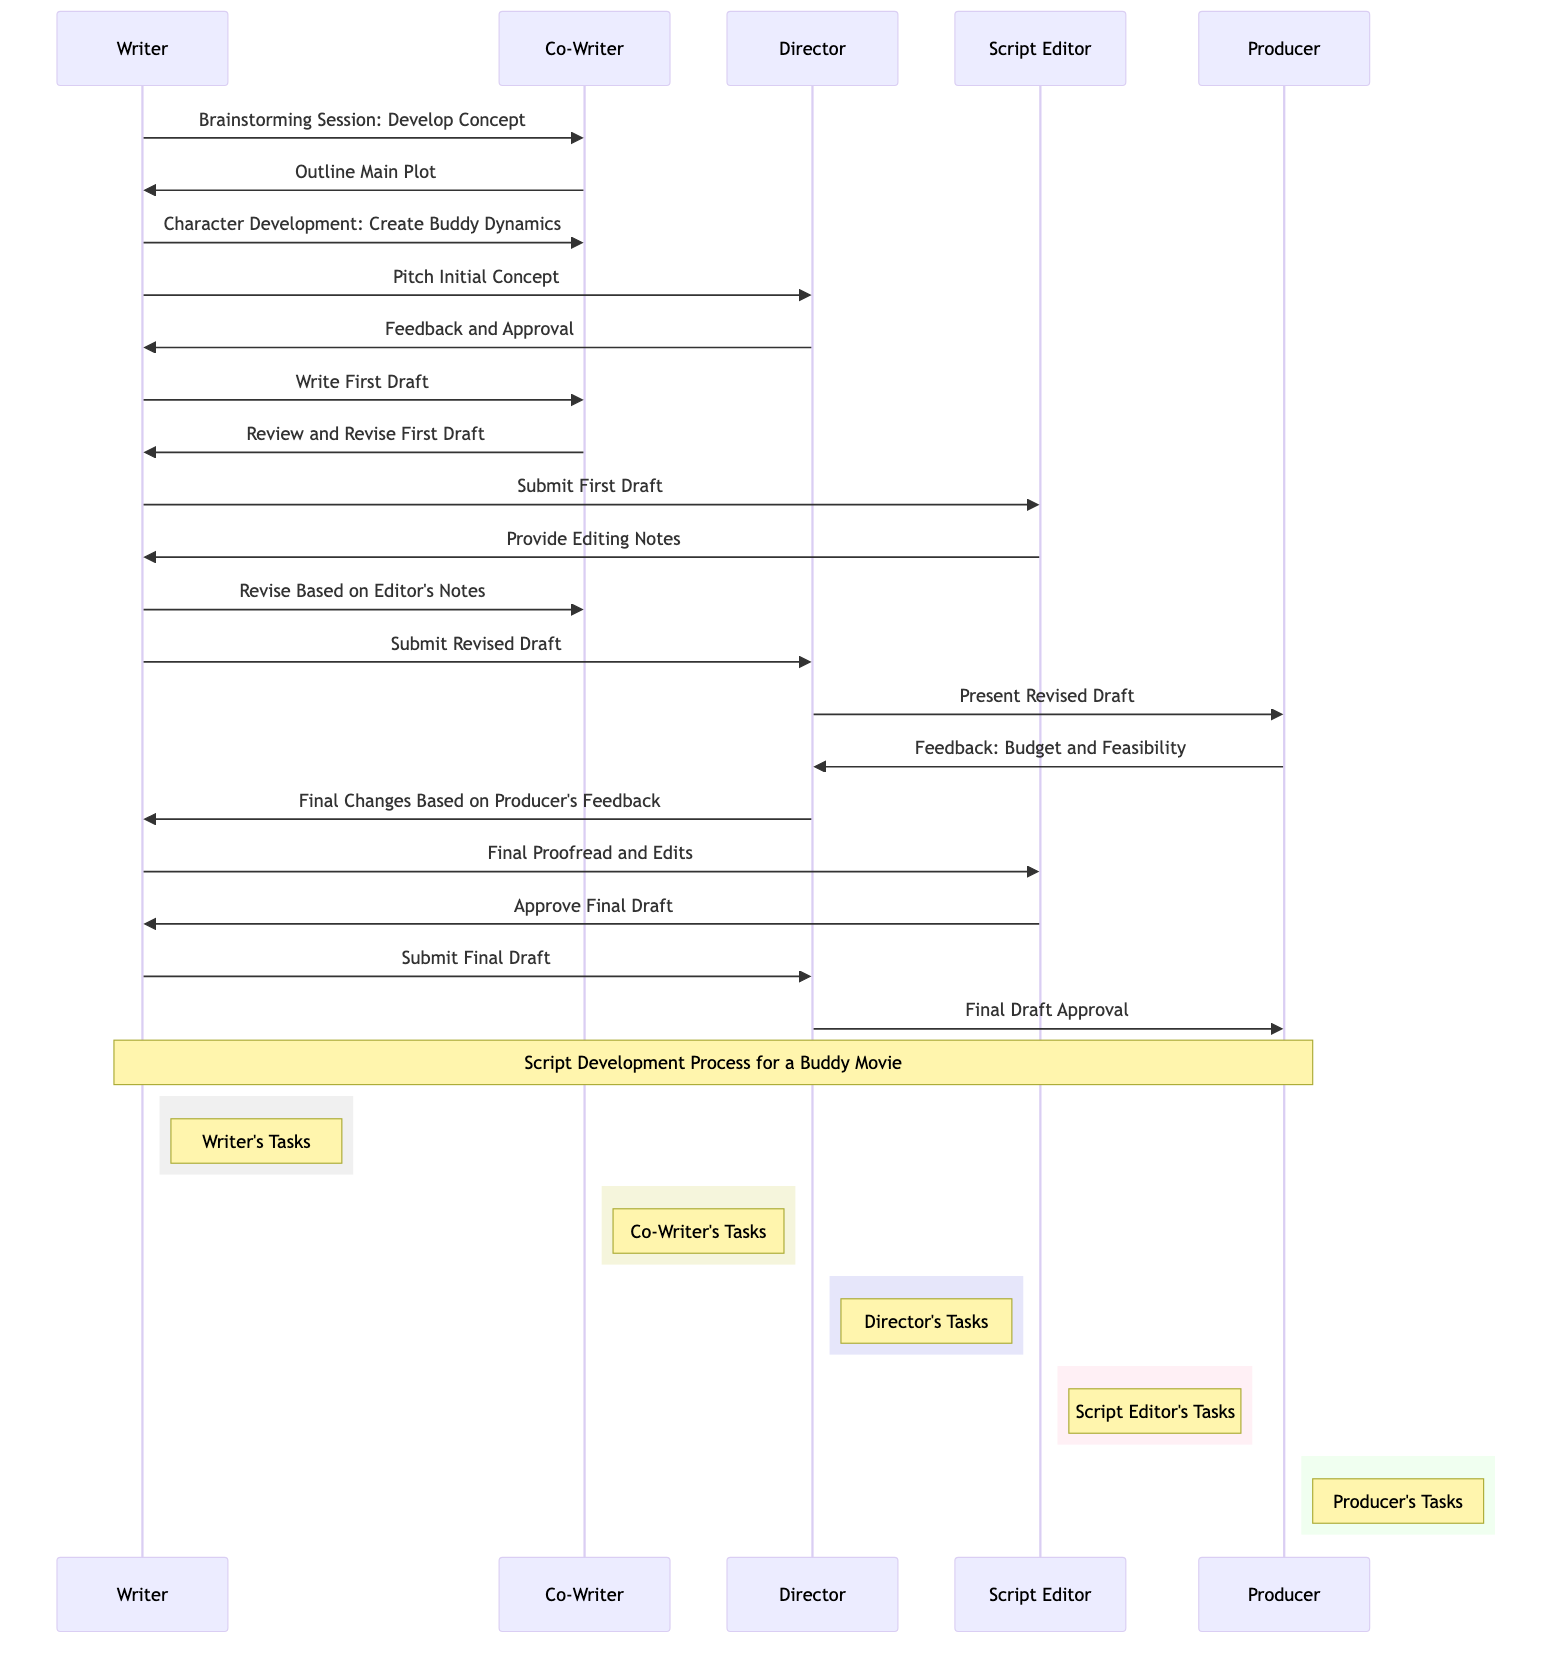What is the first message in the script development process? The first message is from the Writer to the Co-Writer, indicating the start of their collaboration with a brainstorming session to develop the concept.
Answer: Brainstorming Session: Develop Concept How many actors are involved in this sequence diagram? The diagram includes five actors: Writer, Co-Writer, Director, Script Editor, and Producer.
Answer: Five Which actor provides editing notes after receiving the first draft? The Script Editor is responsible for providing editing notes after receiving the first draft from the Writer.
Answer: Script Editor What message does the Director send to the Writer after reviewing the revised draft? The Director sends feedback to the Writer, particularly focused on final changes needed based on the Producer's feedback.
Answer: Final Changes Based on Producer's Feedback How many messages are exchanged between the Writer and Co-Writer? The Writer and Co-Writer exchange four messages throughout the development process in the diagram.
Answer: Four What is the last message in the script development process? The last message is from the Director to the Producer, indicating the final draft approval after receiving the final draft from the Writer.
Answer: Final Draft Approval Which actor is primarily responsible for character development? The Writer is primarily responsible for character development, specifically in creating buddy dynamics.
Answer: Writer In what step does the Producer provide feedback regarding budget and feasibility? The Producer provides feedback regarding budget and feasibility after the Director presents the revised draft.
Answer: After Present Revised Draft 